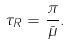<formula> <loc_0><loc_0><loc_500><loc_500>\tau _ { R } = \frac { \pi } { \bar { \mu } } .</formula> 